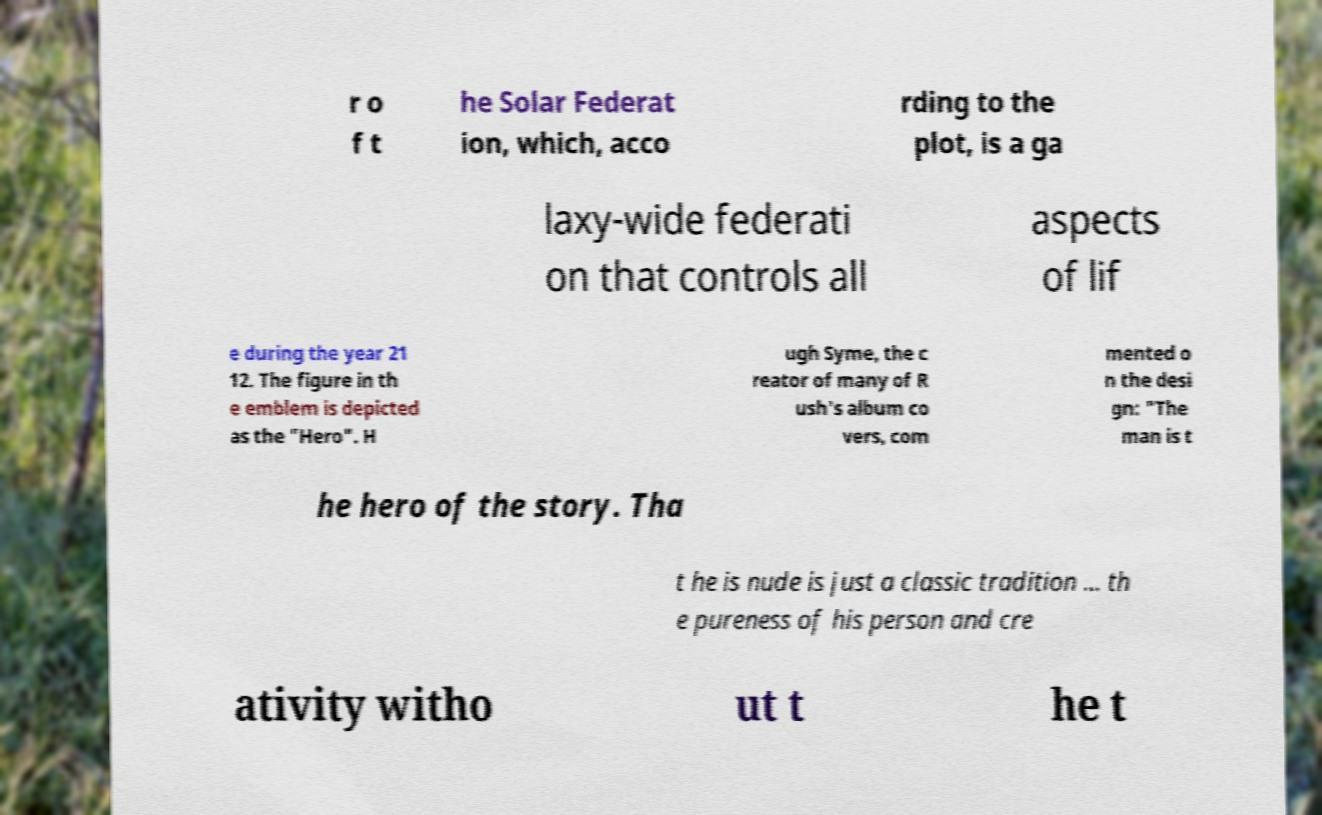Can you accurately transcribe the text from the provided image for me? r o f t he Solar Federat ion, which, acco rding to the plot, is a ga laxy-wide federati on that controls all aspects of lif e during the year 21 12. The figure in th e emblem is depicted as the "Hero". H ugh Syme, the c reator of many of R ush's album co vers, com mented o n the desi gn: "The man is t he hero of the story. Tha t he is nude is just a classic tradition ... th e pureness of his person and cre ativity witho ut t he t 